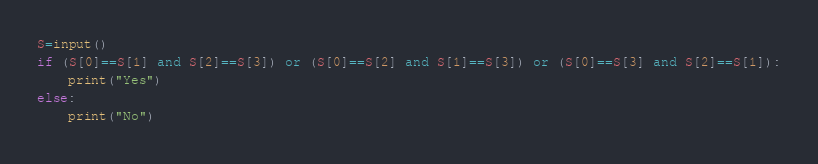Convert code to text. <code><loc_0><loc_0><loc_500><loc_500><_Python_>S=input()
if (S[0]==S[1] and S[2]==S[3]) or (S[0]==S[2] and S[1]==S[3]) or (S[0]==S[3] and S[2]==S[1]):
    print("Yes")
else:
    print("No")</code> 